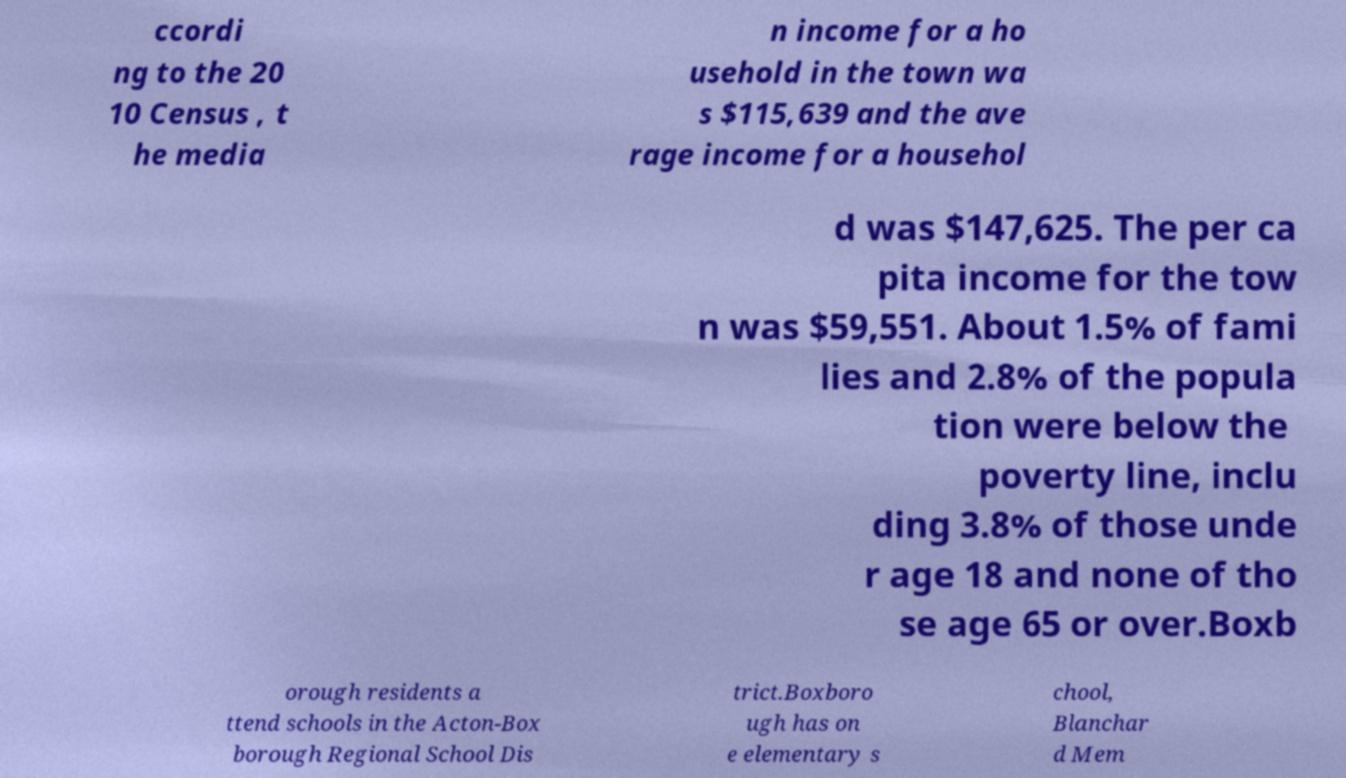Can you read and provide the text displayed in the image?This photo seems to have some interesting text. Can you extract and type it out for me? ccordi ng to the 20 10 Census , t he media n income for a ho usehold in the town wa s $115,639 and the ave rage income for a househol d was $147,625. The per ca pita income for the tow n was $59,551. About 1.5% of fami lies and 2.8% of the popula tion were below the poverty line, inclu ding 3.8% of those unde r age 18 and none of tho se age 65 or over.Boxb orough residents a ttend schools in the Acton-Box borough Regional School Dis trict.Boxboro ugh has on e elementary s chool, Blanchar d Mem 